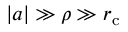Convert formula to latex. <formula><loc_0><loc_0><loc_500><loc_500>| a | \gg \rho \gg r _ { c }</formula> 